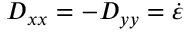<formula> <loc_0><loc_0><loc_500><loc_500>D _ { x x } = - D _ { y y } = \dot { \varepsilon }</formula> 